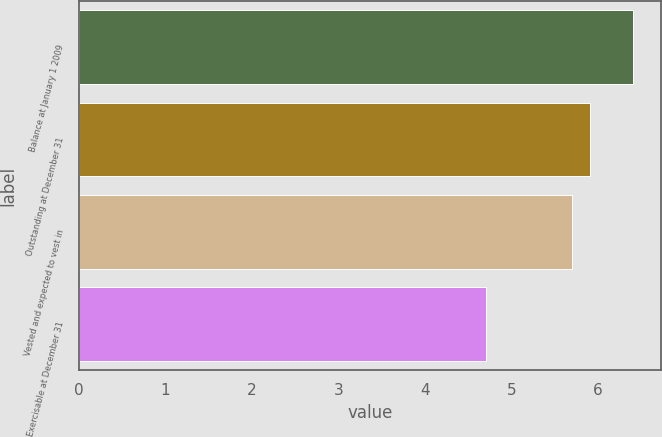Convert chart to OTSL. <chart><loc_0><loc_0><loc_500><loc_500><bar_chart><fcel>Balance at January 1 2009<fcel>Outstanding at December 31<fcel>Vested and expected to vest in<fcel>Exercisable at December 31<nl><fcel>6.4<fcel>5.9<fcel>5.7<fcel>4.7<nl></chart> 